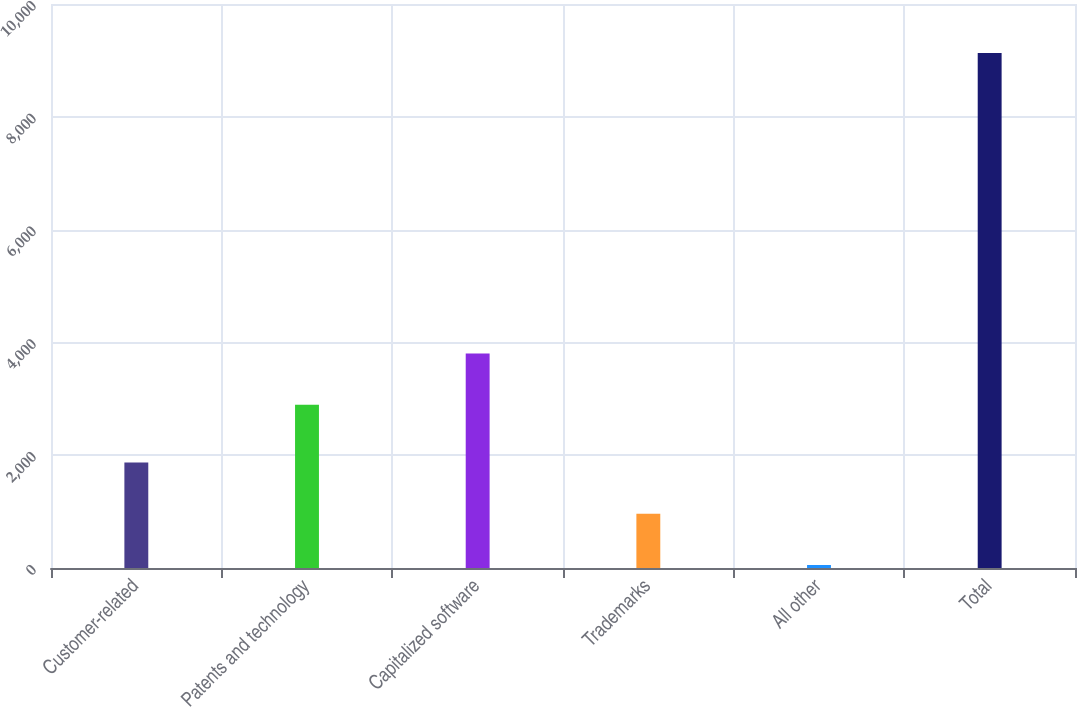<chart> <loc_0><loc_0><loc_500><loc_500><bar_chart><fcel>Customer-related<fcel>Patents and technology<fcel>Capitalized software<fcel>Trademarks<fcel>All other<fcel>Total<nl><fcel>1868.6<fcel>2894<fcel>3801.8<fcel>960.8<fcel>53<fcel>9131<nl></chart> 